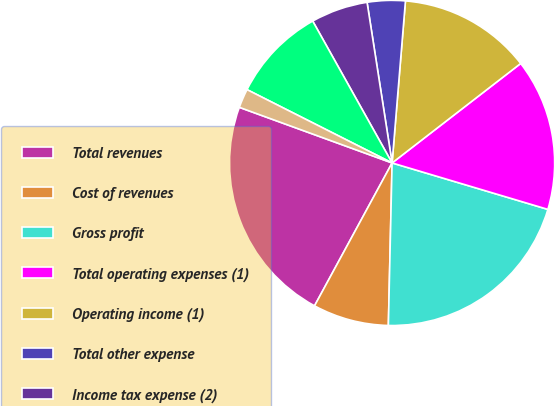Convert chart. <chart><loc_0><loc_0><loc_500><loc_500><pie_chart><fcel>Total revenues<fcel>Cost of revenues<fcel>Gross profit<fcel>Total operating expenses (1)<fcel>Operating income (1)<fcel>Total other expense<fcel>Income tax expense (2)<fcel>Net income (1) (2)<fcel>Net income applicable to<nl><fcel>22.64%<fcel>7.55%<fcel>20.75%<fcel>15.09%<fcel>13.21%<fcel>3.77%<fcel>5.66%<fcel>9.43%<fcel>1.89%<nl></chart> 